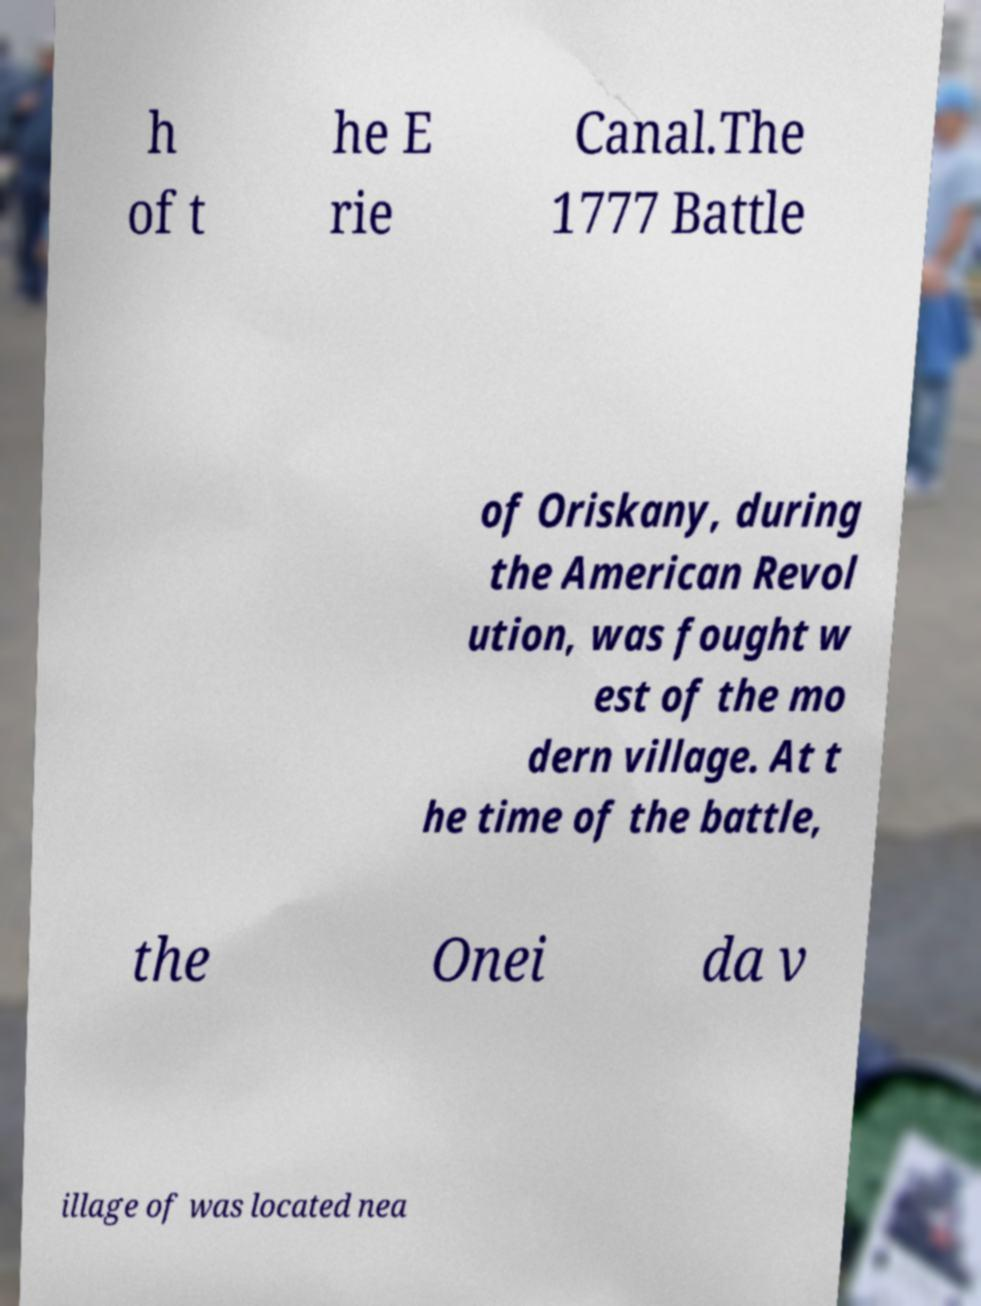Could you assist in decoding the text presented in this image and type it out clearly? h of t he E rie Canal.The 1777 Battle of Oriskany, during the American Revol ution, was fought w est of the mo dern village. At t he time of the battle, the Onei da v illage of was located nea 